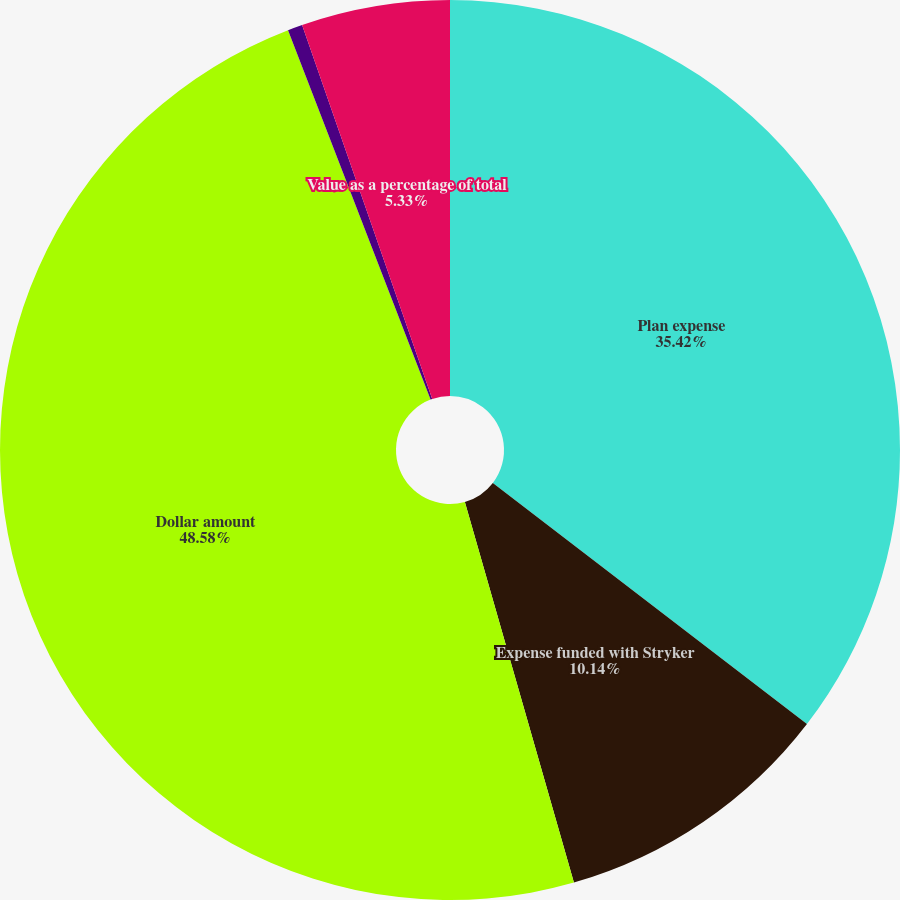Convert chart to OTSL. <chart><loc_0><loc_0><loc_500><loc_500><pie_chart><fcel>Plan expense<fcel>Expense funded with Stryker<fcel>Dollar amount<fcel>Shares (in millions)<fcel>Value as a percentage of total<nl><fcel>35.42%<fcel>10.14%<fcel>48.58%<fcel>0.53%<fcel>5.33%<nl></chart> 